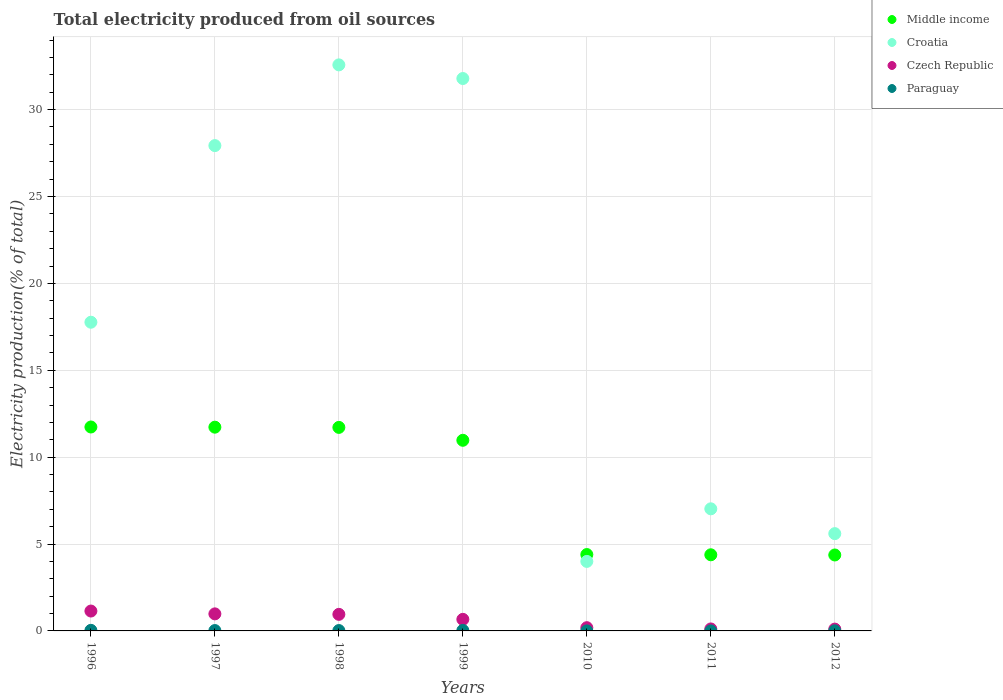How many different coloured dotlines are there?
Your answer should be compact. 4. Is the number of dotlines equal to the number of legend labels?
Offer a terse response. Yes. What is the total electricity produced in Croatia in 1999?
Your answer should be compact. 31.79. Across all years, what is the maximum total electricity produced in Croatia?
Keep it short and to the point. 32.57. Across all years, what is the minimum total electricity produced in Croatia?
Offer a very short reply. 4. In which year was the total electricity produced in Croatia maximum?
Offer a terse response. 1998. What is the total total electricity produced in Croatia in the graph?
Your answer should be very brief. 126.68. What is the difference between the total electricity produced in Paraguay in 1996 and that in 1997?
Give a very brief answer. 0.01. What is the difference between the total electricity produced in Paraguay in 2011 and the total electricity produced in Croatia in 1996?
Offer a very short reply. -17.76. What is the average total electricity produced in Croatia per year?
Ensure brevity in your answer.  18.1. In the year 1999, what is the difference between the total electricity produced in Paraguay and total electricity produced in Croatia?
Offer a very short reply. -31.76. In how many years, is the total electricity produced in Czech Republic greater than 5 %?
Keep it short and to the point. 0. What is the ratio of the total electricity produced in Paraguay in 1997 to that in 2010?
Give a very brief answer. 11.69. Is the total electricity produced in Middle income in 1997 less than that in 2011?
Your answer should be very brief. No. What is the difference between the highest and the second highest total electricity produced in Middle income?
Your answer should be compact. 0.01. What is the difference between the highest and the lowest total electricity produced in Middle income?
Your answer should be compact. 7.37. In how many years, is the total electricity produced in Middle income greater than the average total electricity produced in Middle income taken over all years?
Give a very brief answer. 4. Is the sum of the total electricity produced in Middle income in 1997 and 2012 greater than the maximum total electricity produced in Czech Republic across all years?
Ensure brevity in your answer.  Yes. Does the total electricity produced in Paraguay monotonically increase over the years?
Your answer should be very brief. No. What is the difference between two consecutive major ticks on the Y-axis?
Keep it short and to the point. 5. Are the values on the major ticks of Y-axis written in scientific E-notation?
Your response must be concise. No. Does the graph contain grids?
Keep it short and to the point. Yes. Where does the legend appear in the graph?
Your answer should be very brief. Top right. How many legend labels are there?
Provide a succinct answer. 4. What is the title of the graph?
Provide a succinct answer. Total electricity produced from oil sources. Does "France" appear as one of the legend labels in the graph?
Offer a very short reply. No. What is the label or title of the X-axis?
Ensure brevity in your answer.  Years. What is the label or title of the Y-axis?
Provide a short and direct response. Electricity production(% of total). What is the Electricity production(% of total) of Middle income in 1996?
Make the answer very short. 11.74. What is the Electricity production(% of total) in Croatia in 1996?
Ensure brevity in your answer.  17.76. What is the Electricity production(% of total) of Czech Republic in 1996?
Provide a short and direct response. 1.14. What is the Electricity production(% of total) in Paraguay in 1996?
Keep it short and to the point. 0.03. What is the Electricity production(% of total) in Middle income in 1997?
Ensure brevity in your answer.  11.73. What is the Electricity production(% of total) of Croatia in 1997?
Provide a short and direct response. 27.93. What is the Electricity production(% of total) of Czech Republic in 1997?
Your answer should be compact. 0.98. What is the Electricity production(% of total) of Paraguay in 1997?
Provide a short and direct response. 0.02. What is the Electricity production(% of total) of Middle income in 1998?
Make the answer very short. 11.71. What is the Electricity production(% of total) in Croatia in 1998?
Make the answer very short. 32.57. What is the Electricity production(% of total) in Czech Republic in 1998?
Your response must be concise. 0.95. What is the Electricity production(% of total) in Paraguay in 1998?
Keep it short and to the point. 0.02. What is the Electricity production(% of total) of Middle income in 1999?
Your answer should be very brief. 10.97. What is the Electricity production(% of total) in Croatia in 1999?
Keep it short and to the point. 31.79. What is the Electricity production(% of total) in Czech Republic in 1999?
Keep it short and to the point. 0.67. What is the Electricity production(% of total) in Paraguay in 1999?
Provide a succinct answer. 0.03. What is the Electricity production(% of total) in Middle income in 2010?
Your response must be concise. 4.39. What is the Electricity production(% of total) of Croatia in 2010?
Your answer should be very brief. 4. What is the Electricity production(% of total) in Czech Republic in 2010?
Keep it short and to the point. 0.19. What is the Electricity production(% of total) of Paraguay in 2010?
Provide a short and direct response. 0. What is the Electricity production(% of total) of Middle income in 2011?
Ensure brevity in your answer.  4.38. What is the Electricity production(% of total) in Croatia in 2011?
Provide a short and direct response. 7.03. What is the Electricity production(% of total) in Czech Republic in 2011?
Your response must be concise. 0.11. What is the Electricity production(% of total) in Paraguay in 2011?
Offer a terse response. 0. What is the Electricity production(% of total) of Middle income in 2012?
Offer a terse response. 4.37. What is the Electricity production(% of total) in Croatia in 2012?
Your response must be concise. 5.6. What is the Electricity production(% of total) in Czech Republic in 2012?
Your response must be concise. 0.1. What is the Electricity production(% of total) in Paraguay in 2012?
Your response must be concise. 0. Across all years, what is the maximum Electricity production(% of total) in Middle income?
Provide a short and direct response. 11.74. Across all years, what is the maximum Electricity production(% of total) in Croatia?
Your response must be concise. 32.57. Across all years, what is the maximum Electricity production(% of total) in Czech Republic?
Keep it short and to the point. 1.14. Across all years, what is the maximum Electricity production(% of total) in Paraguay?
Offer a terse response. 0.03. Across all years, what is the minimum Electricity production(% of total) in Middle income?
Keep it short and to the point. 4.37. Across all years, what is the minimum Electricity production(% of total) in Croatia?
Your response must be concise. 4. Across all years, what is the minimum Electricity production(% of total) of Czech Republic?
Offer a terse response. 0.1. Across all years, what is the minimum Electricity production(% of total) in Paraguay?
Ensure brevity in your answer.  0. What is the total Electricity production(% of total) in Middle income in the graph?
Keep it short and to the point. 59.29. What is the total Electricity production(% of total) of Croatia in the graph?
Offer a terse response. 126.68. What is the total Electricity production(% of total) in Czech Republic in the graph?
Keep it short and to the point. 4.15. What is the total Electricity production(% of total) in Paraguay in the graph?
Provide a short and direct response. 0.11. What is the difference between the Electricity production(% of total) in Middle income in 1996 and that in 1997?
Ensure brevity in your answer.  0.01. What is the difference between the Electricity production(% of total) in Croatia in 1996 and that in 1997?
Keep it short and to the point. -10.16. What is the difference between the Electricity production(% of total) of Czech Republic in 1996 and that in 1997?
Provide a short and direct response. 0.16. What is the difference between the Electricity production(% of total) in Paraguay in 1996 and that in 1997?
Provide a short and direct response. 0.01. What is the difference between the Electricity production(% of total) in Middle income in 1996 and that in 1998?
Provide a succinct answer. 0.02. What is the difference between the Electricity production(% of total) in Croatia in 1996 and that in 1998?
Your answer should be compact. -14.81. What is the difference between the Electricity production(% of total) in Czech Republic in 1996 and that in 1998?
Give a very brief answer. 0.19. What is the difference between the Electricity production(% of total) of Paraguay in 1996 and that in 1998?
Offer a terse response. 0.01. What is the difference between the Electricity production(% of total) of Middle income in 1996 and that in 1999?
Provide a succinct answer. 0.76. What is the difference between the Electricity production(% of total) of Croatia in 1996 and that in 1999?
Provide a succinct answer. -14.02. What is the difference between the Electricity production(% of total) in Czech Republic in 1996 and that in 1999?
Make the answer very short. 0.48. What is the difference between the Electricity production(% of total) in Paraguay in 1996 and that in 1999?
Your response must be concise. 0. What is the difference between the Electricity production(% of total) of Middle income in 1996 and that in 2010?
Your answer should be very brief. 7.34. What is the difference between the Electricity production(% of total) of Croatia in 1996 and that in 2010?
Provide a succinct answer. 13.76. What is the difference between the Electricity production(% of total) in Czech Republic in 1996 and that in 2010?
Make the answer very short. 0.96. What is the difference between the Electricity production(% of total) in Paraguay in 1996 and that in 2010?
Offer a terse response. 0.03. What is the difference between the Electricity production(% of total) in Middle income in 1996 and that in 2011?
Ensure brevity in your answer.  7.35. What is the difference between the Electricity production(% of total) of Croatia in 1996 and that in 2011?
Your answer should be very brief. 10.74. What is the difference between the Electricity production(% of total) in Czech Republic in 1996 and that in 2011?
Offer a terse response. 1.03. What is the difference between the Electricity production(% of total) in Paraguay in 1996 and that in 2011?
Provide a succinct answer. 0.03. What is the difference between the Electricity production(% of total) of Middle income in 1996 and that in 2012?
Make the answer very short. 7.37. What is the difference between the Electricity production(% of total) in Croatia in 1996 and that in 2012?
Offer a terse response. 12.17. What is the difference between the Electricity production(% of total) in Czech Republic in 1996 and that in 2012?
Give a very brief answer. 1.04. What is the difference between the Electricity production(% of total) of Paraguay in 1996 and that in 2012?
Your answer should be compact. 0.03. What is the difference between the Electricity production(% of total) of Middle income in 1997 and that in 1998?
Your answer should be compact. 0.01. What is the difference between the Electricity production(% of total) of Croatia in 1997 and that in 1998?
Your response must be concise. -4.65. What is the difference between the Electricity production(% of total) of Czech Republic in 1997 and that in 1998?
Your response must be concise. 0.03. What is the difference between the Electricity production(% of total) in Paraguay in 1997 and that in 1998?
Your answer should be very brief. 0. What is the difference between the Electricity production(% of total) of Middle income in 1997 and that in 1999?
Offer a very short reply. 0.75. What is the difference between the Electricity production(% of total) in Croatia in 1997 and that in 1999?
Give a very brief answer. -3.86. What is the difference between the Electricity production(% of total) of Czech Republic in 1997 and that in 1999?
Your response must be concise. 0.32. What is the difference between the Electricity production(% of total) in Paraguay in 1997 and that in 1999?
Provide a succinct answer. -0.01. What is the difference between the Electricity production(% of total) in Middle income in 1997 and that in 2010?
Offer a very short reply. 7.33. What is the difference between the Electricity production(% of total) of Croatia in 1997 and that in 2010?
Provide a short and direct response. 23.93. What is the difference between the Electricity production(% of total) of Czech Republic in 1997 and that in 2010?
Your response must be concise. 0.79. What is the difference between the Electricity production(% of total) in Paraguay in 1997 and that in 2010?
Your answer should be compact. 0.02. What is the difference between the Electricity production(% of total) in Middle income in 1997 and that in 2011?
Offer a terse response. 7.34. What is the difference between the Electricity production(% of total) in Croatia in 1997 and that in 2011?
Offer a terse response. 20.9. What is the difference between the Electricity production(% of total) of Czech Republic in 1997 and that in 2011?
Your response must be concise. 0.87. What is the difference between the Electricity production(% of total) in Paraguay in 1997 and that in 2011?
Keep it short and to the point. 0.02. What is the difference between the Electricity production(% of total) in Middle income in 1997 and that in 2012?
Your answer should be compact. 7.35. What is the difference between the Electricity production(% of total) in Croatia in 1997 and that in 2012?
Offer a terse response. 22.33. What is the difference between the Electricity production(% of total) of Czech Republic in 1997 and that in 2012?
Your answer should be very brief. 0.88. What is the difference between the Electricity production(% of total) of Paraguay in 1997 and that in 2012?
Offer a very short reply. 0.02. What is the difference between the Electricity production(% of total) in Middle income in 1998 and that in 1999?
Your answer should be very brief. 0.74. What is the difference between the Electricity production(% of total) in Croatia in 1998 and that in 1999?
Your answer should be compact. 0.78. What is the difference between the Electricity production(% of total) in Czech Republic in 1998 and that in 1999?
Your answer should be compact. 0.29. What is the difference between the Electricity production(% of total) of Paraguay in 1998 and that in 1999?
Give a very brief answer. -0.01. What is the difference between the Electricity production(% of total) of Middle income in 1998 and that in 2010?
Your answer should be very brief. 7.32. What is the difference between the Electricity production(% of total) in Croatia in 1998 and that in 2010?
Your answer should be very brief. 28.57. What is the difference between the Electricity production(% of total) in Czech Republic in 1998 and that in 2010?
Your response must be concise. 0.77. What is the difference between the Electricity production(% of total) of Paraguay in 1998 and that in 2010?
Provide a short and direct response. 0.02. What is the difference between the Electricity production(% of total) in Middle income in 1998 and that in 2011?
Keep it short and to the point. 7.33. What is the difference between the Electricity production(% of total) of Croatia in 1998 and that in 2011?
Your answer should be compact. 25.55. What is the difference between the Electricity production(% of total) of Czech Republic in 1998 and that in 2011?
Make the answer very short. 0.84. What is the difference between the Electricity production(% of total) of Paraguay in 1998 and that in 2011?
Your response must be concise. 0.02. What is the difference between the Electricity production(% of total) of Middle income in 1998 and that in 2012?
Offer a very short reply. 7.34. What is the difference between the Electricity production(% of total) of Croatia in 1998 and that in 2012?
Ensure brevity in your answer.  26.98. What is the difference between the Electricity production(% of total) of Czech Republic in 1998 and that in 2012?
Provide a short and direct response. 0.85. What is the difference between the Electricity production(% of total) of Paraguay in 1998 and that in 2012?
Offer a terse response. 0.02. What is the difference between the Electricity production(% of total) of Middle income in 1999 and that in 2010?
Make the answer very short. 6.58. What is the difference between the Electricity production(% of total) of Croatia in 1999 and that in 2010?
Make the answer very short. 27.79. What is the difference between the Electricity production(% of total) in Czech Republic in 1999 and that in 2010?
Provide a short and direct response. 0.48. What is the difference between the Electricity production(% of total) in Paraguay in 1999 and that in 2010?
Keep it short and to the point. 0.03. What is the difference between the Electricity production(% of total) of Middle income in 1999 and that in 2011?
Keep it short and to the point. 6.59. What is the difference between the Electricity production(% of total) in Croatia in 1999 and that in 2011?
Offer a terse response. 24.76. What is the difference between the Electricity production(% of total) in Czech Republic in 1999 and that in 2011?
Your answer should be compact. 0.55. What is the difference between the Electricity production(% of total) in Paraguay in 1999 and that in 2011?
Provide a succinct answer. 0.03. What is the difference between the Electricity production(% of total) of Middle income in 1999 and that in 2012?
Your answer should be very brief. 6.6. What is the difference between the Electricity production(% of total) of Croatia in 1999 and that in 2012?
Keep it short and to the point. 26.19. What is the difference between the Electricity production(% of total) in Czech Republic in 1999 and that in 2012?
Give a very brief answer. 0.56. What is the difference between the Electricity production(% of total) of Paraguay in 1999 and that in 2012?
Offer a terse response. 0.02. What is the difference between the Electricity production(% of total) of Middle income in 2010 and that in 2011?
Your response must be concise. 0.01. What is the difference between the Electricity production(% of total) of Croatia in 2010 and that in 2011?
Your answer should be very brief. -3.03. What is the difference between the Electricity production(% of total) of Czech Republic in 2010 and that in 2011?
Your response must be concise. 0.07. What is the difference between the Electricity production(% of total) in Paraguay in 2010 and that in 2011?
Make the answer very short. 0. What is the difference between the Electricity production(% of total) of Middle income in 2010 and that in 2012?
Give a very brief answer. 0.02. What is the difference between the Electricity production(% of total) in Croatia in 2010 and that in 2012?
Keep it short and to the point. -1.6. What is the difference between the Electricity production(% of total) in Czech Republic in 2010 and that in 2012?
Offer a very short reply. 0.08. What is the difference between the Electricity production(% of total) in Paraguay in 2010 and that in 2012?
Offer a very short reply. -0. What is the difference between the Electricity production(% of total) in Middle income in 2011 and that in 2012?
Give a very brief answer. 0.01. What is the difference between the Electricity production(% of total) of Croatia in 2011 and that in 2012?
Ensure brevity in your answer.  1.43. What is the difference between the Electricity production(% of total) of Czech Republic in 2011 and that in 2012?
Your response must be concise. 0.01. What is the difference between the Electricity production(% of total) in Paraguay in 2011 and that in 2012?
Ensure brevity in your answer.  -0. What is the difference between the Electricity production(% of total) of Middle income in 1996 and the Electricity production(% of total) of Croatia in 1997?
Offer a terse response. -16.19. What is the difference between the Electricity production(% of total) of Middle income in 1996 and the Electricity production(% of total) of Czech Republic in 1997?
Your answer should be very brief. 10.75. What is the difference between the Electricity production(% of total) in Middle income in 1996 and the Electricity production(% of total) in Paraguay in 1997?
Ensure brevity in your answer.  11.71. What is the difference between the Electricity production(% of total) in Croatia in 1996 and the Electricity production(% of total) in Czech Republic in 1997?
Your answer should be very brief. 16.78. What is the difference between the Electricity production(% of total) of Croatia in 1996 and the Electricity production(% of total) of Paraguay in 1997?
Keep it short and to the point. 17.74. What is the difference between the Electricity production(% of total) of Czech Republic in 1996 and the Electricity production(% of total) of Paraguay in 1997?
Provide a short and direct response. 1.12. What is the difference between the Electricity production(% of total) of Middle income in 1996 and the Electricity production(% of total) of Croatia in 1998?
Provide a short and direct response. -20.84. What is the difference between the Electricity production(% of total) of Middle income in 1996 and the Electricity production(% of total) of Czech Republic in 1998?
Keep it short and to the point. 10.78. What is the difference between the Electricity production(% of total) in Middle income in 1996 and the Electricity production(% of total) in Paraguay in 1998?
Provide a short and direct response. 11.71. What is the difference between the Electricity production(% of total) in Croatia in 1996 and the Electricity production(% of total) in Czech Republic in 1998?
Provide a short and direct response. 16.81. What is the difference between the Electricity production(% of total) in Croatia in 1996 and the Electricity production(% of total) in Paraguay in 1998?
Your answer should be compact. 17.74. What is the difference between the Electricity production(% of total) in Czech Republic in 1996 and the Electricity production(% of total) in Paraguay in 1998?
Make the answer very short. 1.12. What is the difference between the Electricity production(% of total) of Middle income in 1996 and the Electricity production(% of total) of Croatia in 1999?
Give a very brief answer. -20.05. What is the difference between the Electricity production(% of total) in Middle income in 1996 and the Electricity production(% of total) in Czech Republic in 1999?
Provide a short and direct response. 11.07. What is the difference between the Electricity production(% of total) of Middle income in 1996 and the Electricity production(% of total) of Paraguay in 1999?
Your answer should be compact. 11.71. What is the difference between the Electricity production(% of total) of Croatia in 1996 and the Electricity production(% of total) of Czech Republic in 1999?
Make the answer very short. 17.1. What is the difference between the Electricity production(% of total) in Croatia in 1996 and the Electricity production(% of total) in Paraguay in 1999?
Give a very brief answer. 17.74. What is the difference between the Electricity production(% of total) of Czech Republic in 1996 and the Electricity production(% of total) of Paraguay in 1999?
Your answer should be compact. 1.11. What is the difference between the Electricity production(% of total) of Middle income in 1996 and the Electricity production(% of total) of Croatia in 2010?
Give a very brief answer. 7.74. What is the difference between the Electricity production(% of total) in Middle income in 1996 and the Electricity production(% of total) in Czech Republic in 2010?
Make the answer very short. 11.55. What is the difference between the Electricity production(% of total) of Middle income in 1996 and the Electricity production(% of total) of Paraguay in 2010?
Your response must be concise. 11.73. What is the difference between the Electricity production(% of total) in Croatia in 1996 and the Electricity production(% of total) in Czech Republic in 2010?
Provide a succinct answer. 17.58. What is the difference between the Electricity production(% of total) in Croatia in 1996 and the Electricity production(% of total) in Paraguay in 2010?
Offer a very short reply. 17.76. What is the difference between the Electricity production(% of total) in Czech Republic in 1996 and the Electricity production(% of total) in Paraguay in 2010?
Make the answer very short. 1.14. What is the difference between the Electricity production(% of total) of Middle income in 1996 and the Electricity production(% of total) of Croatia in 2011?
Provide a succinct answer. 4.71. What is the difference between the Electricity production(% of total) of Middle income in 1996 and the Electricity production(% of total) of Czech Republic in 2011?
Give a very brief answer. 11.62. What is the difference between the Electricity production(% of total) of Middle income in 1996 and the Electricity production(% of total) of Paraguay in 2011?
Give a very brief answer. 11.73. What is the difference between the Electricity production(% of total) in Croatia in 1996 and the Electricity production(% of total) in Czech Republic in 2011?
Offer a terse response. 17.65. What is the difference between the Electricity production(% of total) in Croatia in 1996 and the Electricity production(% of total) in Paraguay in 2011?
Provide a succinct answer. 17.76. What is the difference between the Electricity production(% of total) in Czech Republic in 1996 and the Electricity production(% of total) in Paraguay in 2011?
Your answer should be compact. 1.14. What is the difference between the Electricity production(% of total) in Middle income in 1996 and the Electricity production(% of total) in Croatia in 2012?
Give a very brief answer. 6.14. What is the difference between the Electricity production(% of total) of Middle income in 1996 and the Electricity production(% of total) of Czech Republic in 2012?
Make the answer very short. 11.63. What is the difference between the Electricity production(% of total) in Middle income in 1996 and the Electricity production(% of total) in Paraguay in 2012?
Ensure brevity in your answer.  11.73. What is the difference between the Electricity production(% of total) of Croatia in 1996 and the Electricity production(% of total) of Czech Republic in 2012?
Make the answer very short. 17.66. What is the difference between the Electricity production(% of total) in Croatia in 1996 and the Electricity production(% of total) in Paraguay in 2012?
Offer a terse response. 17.76. What is the difference between the Electricity production(% of total) of Czech Republic in 1996 and the Electricity production(% of total) of Paraguay in 2012?
Make the answer very short. 1.14. What is the difference between the Electricity production(% of total) of Middle income in 1997 and the Electricity production(% of total) of Croatia in 1998?
Give a very brief answer. -20.85. What is the difference between the Electricity production(% of total) in Middle income in 1997 and the Electricity production(% of total) in Czech Republic in 1998?
Offer a very short reply. 10.77. What is the difference between the Electricity production(% of total) in Middle income in 1997 and the Electricity production(% of total) in Paraguay in 1998?
Ensure brevity in your answer.  11.7. What is the difference between the Electricity production(% of total) of Croatia in 1997 and the Electricity production(% of total) of Czech Republic in 1998?
Your response must be concise. 26.98. What is the difference between the Electricity production(% of total) of Croatia in 1997 and the Electricity production(% of total) of Paraguay in 1998?
Your answer should be compact. 27.91. What is the difference between the Electricity production(% of total) of Czech Republic in 1997 and the Electricity production(% of total) of Paraguay in 1998?
Ensure brevity in your answer.  0.96. What is the difference between the Electricity production(% of total) in Middle income in 1997 and the Electricity production(% of total) in Croatia in 1999?
Provide a succinct answer. -20.06. What is the difference between the Electricity production(% of total) in Middle income in 1997 and the Electricity production(% of total) in Czech Republic in 1999?
Your answer should be very brief. 11.06. What is the difference between the Electricity production(% of total) of Middle income in 1997 and the Electricity production(% of total) of Paraguay in 1999?
Your answer should be very brief. 11.7. What is the difference between the Electricity production(% of total) in Croatia in 1997 and the Electricity production(% of total) in Czech Republic in 1999?
Your response must be concise. 27.26. What is the difference between the Electricity production(% of total) in Croatia in 1997 and the Electricity production(% of total) in Paraguay in 1999?
Your answer should be compact. 27.9. What is the difference between the Electricity production(% of total) in Czech Republic in 1997 and the Electricity production(% of total) in Paraguay in 1999?
Offer a terse response. 0.95. What is the difference between the Electricity production(% of total) of Middle income in 1997 and the Electricity production(% of total) of Croatia in 2010?
Offer a terse response. 7.72. What is the difference between the Electricity production(% of total) of Middle income in 1997 and the Electricity production(% of total) of Czech Republic in 2010?
Offer a terse response. 11.54. What is the difference between the Electricity production(% of total) of Middle income in 1997 and the Electricity production(% of total) of Paraguay in 2010?
Provide a succinct answer. 11.72. What is the difference between the Electricity production(% of total) of Croatia in 1997 and the Electricity production(% of total) of Czech Republic in 2010?
Your response must be concise. 27.74. What is the difference between the Electricity production(% of total) of Croatia in 1997 and the Electricity production(% of total) of Paraguay in 2010?
Provide a short and direct response. 27.93. What is the difference between the Electricity production(% of total) of Czech Republic in 1997 and the Electricity production(% of total) of Paraguay in 2010?
Your answer should be compact. 0.98. What is the difference between the Electricity production(% of total) of Middle income in 1997 and the Electricity production(% of total) of Croatia in 2011?
Give a very brief answer. 4.7. What is the difference between the Electricity production(% of total) in Middle income in 1997 and the Electricity production(% of total) in Czech Republic in 2011?
Provide a succinct answer. 11.61. What is the difference between the Electricity production(% of total) in Middle income in 1997 and the Electricity production(% of total) in Paraguay in 2011?
Ensure brevity in your answer.  11.72. What is the difference between the Electricity production(% of total) in Croatia in 1997 and the Electricity production(% of total) in Czech Republic in 2011?
Keep it short and to the point. 27.81. What is the difference between the Electricity production(% of total) in Croatia in 1997 and the Electricity production(% of total) in Paraguay in 2011?
Ensure brevity in your answer.  27.93. What is the difference between the Electricity production(% of total) of Czech Republic in 1997 and the Electricity production(% of total) of Paraguay in 2011?
Your response must be concise. 0.98. What is the difference between the Electricity production(% of total) of Middle income in 1997 and the Electricity production(% of total) of Croatia in 2012?
Ensure brevity in your answer.  6.13. What is the difference between the Electricity production(% of total) of Middle income in 1997 and the Electricity production(% of total) of Czech Republic in 2012?
Ensure brevity in your answer.  11.62. What is the difference between the Electricity production(% of total) in Middle income in 1997 and the Electricity production(% of total) in Paraguay in 2012?
Your answer should be very brief. 11.72. What is the difference between the Electricity production(% of total) of Croatia in 1997 and the Electricity production(% of total) of Czech Republic in 2012?
Give a very brief answer. 27.82. What is the difference between the Electricity production(% of total) in Croatia in 1997 and the Electricity production(% of total) in Paraguay in 2012?
Your response must be concise. 27.92. What is the difference between the Electricity production(% of total) in Czech Republic in 1997 and the Electricity production(% of total) in Paraguay in 2012?
Your response must be concise. 0.98. What is the difference between the Electricity production(% of total) of Middle income in 1998 and the Electricity production(% of total) of Croatia in 1999?
Your answer should be compact. -20.08. What is the difference between the Electricity production(% of total) of Middle income in 1998 and the Electricity production(% of total) of Czech Republic in 1999?
Your answer should be very brief. 11.05. What is the difference between the Electricity production(% of total) in Middle income in 1998 and the Electricity production(% of total) in Paraguay in 1999?
Keep it short and to the point. 11.68. What is the difference between the Electricity production(% of total) of Croatia in 1998 and the Electricity production(% of total) of Czech Republic in 1999?
Ensure brevity in your answer.  31.91. What is the difference between the Electricity production(% of total) of Croatia in 1998 and the Electricity production(% of total) of Paraguay in 1999?
Your answer should be very brief. 32.55. What is the difference between the Electricity production(% of total) of Czech Republic in 1998 and the Electricity production(% of total) of Paraguay in 1999?
Make the answer very short. 0.92. What is the difference between the Electricity production(% of total) in Middle income in 1998 and the Electricity production(% of total) in Croatia in 2010?
Ensure brevity in your answer.  7.71. What is the difference between the Electricity production(% of total) of Middle income in 1998 and the Electricity production(% of total) of Czech Republic in 2010?
Offer a terse response. 11.53. What is the difference between the Electricity production(% of total) of Middle income in 1998 and the Electricity production(% of total) of Paraguay in 2010?
Give a very brief answer. 11.71. What is the difference between the Electricity production(% of total) in Croatia in 1998 and the Electricity production(% of total) in Czech Republic in 2010?
Give a very brief answer. 32.39. What is the difference between the Electricity production(% of total) in Croatia in 1998 and the Electricity production(% of total) in Paraguay in 2010?
Make the answer very short. 32.57. What is the difference between the Electricity production(% of total) in Czech Republic in 1998 and the Electricity production(% of total) in Paraguay in 2010?
Your answer should be very brief. 0.95. What is the difference between the Electricity production(% of total) of Middle income in 1998 and the Electricity production(% of total) of Croatia in 2011?
Give a very brief answer. 4.69. What is the difference between the Electricity production(% of total) in Middle income in 1998 and the Electricity production(% of total) in Czech Republic in 2011?
Make the answer very short. 11.6. What is the difference between the Electricity production(% of total) in Middle income in 1998 and the Electricity production(% of total) in Paraguay in 2011?
Your answer should be compact. 11.71. What is the difference between the Electricity production(% of total) of Croatia in 1998 and the Electricity production(% of total) of Czech Republic in 2011?
Make the answer very short. 32.46. What is the difference between the Electricity production(% of total) of Croatia in 1998 and the Electricity production(% of total) of Paraguay in 2011?
Give a very brief answer. 32.57. What is the difference between the Electricity production(% of total) in Czech Republic in 1998 and the Electricity production(% of total) in Paraguay in 2011?
Your answer should be compact. 0.95. What is the difference between the Electricity production(% of total) in Middle income in 1998 and the Electricity production(% of total) in Croatia in 2012?
Provide a succinct answer. 6.11. What is the difference between the Electricity production(% of total) in Middle income in 1998 and the Electricity production(% of total) in Czech Republic in 2012?
Ensure brevity in your answer.  11.61. What is the difference between the Electricity production(% of total) in Middle income in 1998 and the Electricity production(% of total) in Paraguay in 2012?
Keep it short and to the point. 11.71. What is the difference between the Electricity production(% of total) in Croatia in 1998 and the Electricity production(% of total) in Czech Republic in 2012?
Your answer should be very brief. 32.47. What is the difference between the Electricity production(% of total) in Croatia in 1998 and the Electricity production(% of total) in Paraguay in 2012?
Your answer should be compact. 32.57. What is the difference between the Electricity production(% of total) in Czech Republic in 1998 and the Electricity production(% of total) in Paraguay in 2012?
Keep it short and to the point. 0.95. What is the difference between the Electricity production(% of total) in Middle income in 1999 and the Electricity production(% of total) in Croatia in 2010?
Your answer should be compact. 6.97. What is the difference between the Electricity production(% of total) of Middle income in 1999 and the Electricity production(% of total) of Czech Republic in 2010?
Make the answer very short. 10.78. What is the difference between the Electricity production(% of total) in Middle income in 1999 and the Electricity production(% of total) in Paraguay in 2010?
Your answer should be compact. 10.97. What is the difference between the Electricity production(% of total) in Croatia in 1999 and the Electricity production(% of total) in Czech Republic in 2010?
Ensure brevity in your answer.  31.6. What is the difference between the Electricity production(% of total) of Croatia in 1999 and the Electricity production(% of total) of Paraguay in 2010?
Keep it short and to the point. 31.79. What is the difference between the Electricity production(% of total) in Czech Republic in 1999 and the Electricity production(% of total) in Paraguay in 2010?
Give a very brief answer. 0.66. What is the difference between the Electricity production(% of total) in Middle income in 1999 and the Electricity production(% of total) in Croatia in 2011?
Your answer should be compact. 3.94. What is the difference between the Electricity production(% of total) in Middle income in 1999 and the Electricity production(% of total) in Czech Republic in 2011?
Offer a very short reply. 10.86. What is the difference between the Electricity production(% of total) in Middle income in 1999 and the Electricity production(% of total) in Paraguay in 2011?
Offer a terse response. 10.97. What is the difference between the Electricity production(% of total) of Croatia in 1999 and the Electricity production(% of total) of Czech Republic in 2011?
Keep it short and to the point. 31.68. What is the difference between the Electricity production(% of total) of Croatia in 1999 and the Electricity production(% of total) of Paraguay in 2011?
Your response must be concise. 31.79. What is the difference between the Electricity production(% of total) of Czech Republic in 1999 and the Electricity production(% of total) of Paraguay in 2011?
Keep it short and to the point. 0.66. What is the difference between the Electricity production(% of total) of Middle income in 1999 and the Electricity production(% of total) of Croatia in 2012?
Give a very brief answer. 5.37. What is the difference between the Electricity production(% of total) of Middle income in 1999 and the Electricity production(% of total) of Czech Republic in 2012?
Your response must be concise. 10.87. What is the difference between the Electricity production(% of total) in Middle income in 1999 and the Electricity production(% of total) in Paraguay in 2012?
Make the answer very short. 10.97. What is the difference between the Electricity production(% of total) in Croatia in 1999 and the Electricity production(% of total) in Czech Republic in 2012?
Ensure brevity in your answer.  31.68. What is the difference between the Electricity production(% of total) of Croatia in 1999 and the Electricity production(% of total) of Paraguay in 2012?
Provide a short and direct response. 31.78. What is the difference between the Electricity production(% of total) of Czech Republic in 1999 and the Electricity production(% of total) of Paraguay in 2012?
Your answer should be compact. 0.66. What is the difference between the Electricity production(% of total) in Middle income in 2010 and the Electricity production(% of total) in Croatia in 2011?
Keep it short and to the point. -2.63. What is the difference between the Electricity production(% of total) in Middle income in 2010 and the Electricity production(% of total) in Czech Republic in 2011?
Offer a terse response. 4.28. What is the difference between the Electricity production(% of total) in Middle income in 2010 and the Electricity production(% of total) in Paraguay in 2011?
Provide a short and direct response. 4.39. What is the difference between the Electricity production(% of total) of Croatia in 2010 and the Electricity production(% of total) of Czech Republic in 2011?
Provide a short and direct response. 3.89. What is the difference between the Electricity production(% of total) in Croatia in 2010 and the Electricity production(% of total) in Paraguay in 2011?
Your response must be concise. 4. What is the difference between the Electricity production(% of total) of Czech Republic in 2010 and the Electricity production(% of total) of Paraguay in 2011?
Keep it short and to the point. 0.18. What is the difference between the Electricity production(% of total) in Middle income in 2010 and the Electricity production(% of total) in Croatia in 2012?
Provide a succinct answer. -1.2. What is the difference between the Electricity production(% of total) of Middle income in 2010 and the Electricity production(% of total) of Czech Republic in 2012?
Make the answer very short. 4.29. What is the difference between the Electricity production(% of total) in Middle income in 2010 and the Electricity production(% of total) in Paraguay in 2012?
Provide a succinct answer. 4.39. What is the difference between the Electricity production(% of total) in Croatia in 2010 and the Electricity production(% of total) in Czech Republic in 2012?
Provide a short and direct response. 3.9. What is the difference between the Electricity production(% of total) of Croatia in 2010 and the Electricity production(% of total) of Paraguay in 2012?
Keep it short and to the point. 4. What is the difference between the Electricity production(% of total) in Czech Republic in 2010 and the Electricity production(% of total) in Paraguay in 2012?
Ensure brevity in your answer.  0.18. What is the difference between the Electricity production(% of total) in Middle income in 2011 and the Electricity production(% of total) in Croatia in 2012?
Your response must be concise. -1.22. What is the difference between the Electricity production(% of total) in Middle income in 2011 and the Electricity production(% of total) in Czech Republic in 2012?
Your answer should be very brief. 4.28. What is the difference between the Electricity production(% of total) of Middle income in 2011 and the Electricity production(% of total) of Paraguay in 2012?
Your answer should be compact. 4.38. What is the difference between the Electricity production(% of total) in Croatia in 2011 and the Electricity production(% of total) in Czech Republic in 2012?
Your response must be concise. 6.92. What is the difference between the Electricity production(% of total) of Croatia in 2011 and the Electricity production(% of total) of Paraguay in 2012?
Provide a succinct answer. 7.02. What is the difference between the Electricity production(% of total) of Czech Republic in 2011 and the Electricity production(% of total) of Paraguay in 2012?
Ensure brevity in your answer.  0.11. What is the average Electricity production(% of total) of Middle income per year?
Offer a terse response. 8.47. What is the average Electricity production(% of total) of Croatia per year?
Provide a short and direct response. 18.1. What is the average Electricity production(% of total) of Czech Republic per year?
Make the answer very short. 0.59. What is the average Electricity production(% of total) of Paraguay per year?
Keep it short and to the point. 0.02. In the year 1996, what is the difference between the Electricity production(% of total) in Middle income and Electricity production(% of total) in Croatia?
Ensure brevity in your answer.  -6.03. In the year 1996, what is the difference between the Electricity production(% of total) in Middle income and Electricity production(% of total) in Czech Republic?
Ensure brevity in your answer.  10.59. In the year 1996, what is the difference between the Electricity production(% of total) in Middle income and Electricity production(% of total) in Paraguay?
Provide a short and direct response. 11.7. In the year 1996, what is the difference between the Electricity production(% of total) of Croatia and Electricity production(% of total) of Czech Republic?
Your answer should be very brief. 16.62. In the year 1996, what is the difference between the Electricity production(% of total) of Croatia and Electricity production(% of total) of Paraguay?
Your response must be concise. 17.73. In the year 1996, what is the difference between the Electricity production(% of total) in Czech Republic and Electricity production(% of total) in Paraguay?
Give a very brief answer. 1.11. In the year 1997, what is the difference between the Electricity production(% of total) in Middle income and Electricity production(% of total) in Croatia?
Make the answer very short. -16.2. In the year 1997, what is the difference between the Electricity production(% of total) in Middle income and Electricity production(% of total) in Czech Republic?
Provide a succinct answer. 10.74. In the year 1997, what is the difference between the Electricity production(% of total) of Middle income and Electricity production(% of total) of Paraguay?
Provide a succinct answer. 11.7. In the year 1997, what is the difference between the Electricity production(% of total) of Croatia and Electricity production(% of total) of Czech Republic?
Provide a succinct answer. 26.95. In the year 1997, what is the difference between the Electricity production(% of total) in Croatia and Electricity production(% of total) in Paraguay?
Give a very brief answer. 27.91. In the year 1997, what is the difference between the Electricity production(% of total) of Czech Republic and Electricity production(% of total) of Paraguay?
Provide a short and direct response. 0.96. In the year 1998, what is the difference between the Electricity production(% of total) in Middle income and Electricity production(% of total) in Croatia?
Keep it short and to the point. -20.86. In the year 1998, what is the difference between the Electricity production(% of total) in Middle income and Electricity production(% of total) in Czech Republic?
Offer a very short reply. 10.76. In the year 1998, what is the difference between the Electricity production(% of total) in Middle income and Electricity production(% of total) in Paraguay?
Your response must be concise. 11.69. In the year 1998, what is the difference between the Electricity production(% of total) in Croatia and Electricity production(% of total) in Czech Republic?
Offer a terse response. 31.62. In the year 1998, what is the difference between the Electricity production(% of total) of Croatia and Electricity production(% of total) of Paraguay?
Offer a terse response. 32.55. In the year 1998, what is the difference between the Electricity production(% of total) of Czech Republic and Electricity production(% of total) of Paraguay?
Keep it short and to the point. 0.93. In the year 1999, what is the difference between the Electricity production(% of total) of Middle income and Electricity production(% of total) of Croatia?
Your answer should be compact. -20.82. In the year 1999, what is the difference between the Electricity production(% of total) of Middle income and Electricity production(% of total) of Czech Republic?
Offer a very short reply. 10.3. In the year 1999, what is the difference between the Electricity production(% of total) of Middle income and Electricity production(% of total) of Paraguay?
Ensure brevity in your answer.  10.94. In the year 1999, what is the difference between the Electricity production(% of total) in Croatia and Electricity production(% of total) in Czech Republic?
Offer a very short reply. 31.12. In the year 1999, what is the difference between the Electricity production(% of total) in Croatia and Electricity production(% of total) in Paraguay?
Your answer should be very brief. 31.76. In the year 1999, what is the difference between the Electricity production(% of total) of Czech Republic and Electricity production(% of total) of Paraguay?
Ensure brevity in your answer.  0.64. In the year 2010, what is the difference between the Electricity production(% of total) of Middle income and Electricity production(% of total) of Croatia?
Keep it short and to the point. 0.39. In the year 2010, what is the difference between the Electricity production(% of total) in Middle income and Electricity production(% of total) in Czech Republic?
Provide a succinct answer. 4.21. In the year 2010, what is the difference between the Electricity production(% of total) in Middle income and Electricity production(% of total) in Paraguay?
Offer a terse response. 4.39. In the year 2010, what is the difference between the Electricity production(% of total) in Croatia and Electricity production(% of total) in Czech Republic?
Offer a very short reply. 3.81. In the year 2010, what is the difference between the Electricity production(% of total) of Croatia and Electricity production(% of total) of Paraguay?
Give a very brief answer. 4. In the year 2010, what is the difference between the Electricity production(% of total) in Czech Republic and Electricity production(% of total) in Paraguay?
Offer a very short reply. 0.18. In the year 2011, what is the difference between the Electricity production(% of total) in Middle income and Electricity production(% of total) in Croatia?
Offer a very short reply. -2.65. In the year 2011, what is the difference between the Electricity production(% of total) in Middle income and Electricity production(% of total) in Czech Republic?
Keep it short and to the point. 4.27. In the year 2011, what is the difference between the Electricity production(% of total) in Middle income and Electricity production(% of total) in Paraguay?
Provide a short and direct response. 4.38. In the year 2011, what is the difference between the Electricity production(% of total) in Croatia and Electricity production(% of total) in Czech Republic?
Ensure brevity in your answer.  6.91. In the year 2011, what is the difference between the Electricity production(% of total) of Croatia and Electricity production(% of total) of Paraguay?
Offer a terse response. 7.03. In the year 2011, what is the difference between the Electricity production(% of total) of Czech Republic and Electricity production(% of total) of Paraguay?
Provide a short and direct response. 0.11. In the year 2012, what is the difference between the Electricity production(% of total) in Middle income and Electricity production(% of total) in Croatia?
Your answer should be very brief. -1.23. In the year 2012, what is the difference between the Electricity production(% of total) of Middle income and Electricity production(% of total) of Czech Republic?
Your response must be concise. 4.27. In the year 2012, what is the difference between the Electricity production(% of total) of Middle income and Electricity production(% of total) of Paraguay?
Your response must be concise. 4.37. In the year 2012, what is the difference between the Electricity production(% of total) in Croatia and Electricity production(% of total) in Czech Republic?
Your answer should be compact. 5.49. In the year 2012, what is the difference between the Electricity production(% of total) in Croatia and Electricity production(% of total) in Paraguay?
Your response must be concise. 5.59. In the year 2012, what is the difference between the Electricity production(% of total) in Czech Republic and Electricity production(% of total) in Paraguay?
Ensure brevity in your answer.  0.1. What is the ratio of the Electricity production(% of total) in Middle income in 1996 to that in 1997?
Ensure brevity in your answer.  1. What is the ratio of the Electricity production(% of total) of Croatia in 1996 to that in 1997?
Provide a succinct answer. 0.64. What is the ratio of the Electricity production(% of total) in Czech Republic in 1996 to that in 1997?
Your response must be concise. 1.17. What is the ratio of the Electricity production(% of total) in Paraguay in 1996 to that in 1997?
Offer a terse response. 1.55. What is the ratio of the Electricity production(% of total) in Croatia in 1996 to that in 1998?
Make the answer very short. 0.55. What is the ratio of the Electricity production(% of total) in Czech Republic in 1996 to that in 1998?
Offer a terse response. 1.2. What is the ratio of the Electricity production(% of total) in Paraguay in 1996 to that in 1998?
Offer a terse response. 1.55. What is the ratio of the Electricity production(% of total) in Middle income in 1996 to that in 1999?
Give a very brief answer. 1.07. What is the ratio of the Electricity production(% of total) of Croatia in 1996 to that in 1999?
Ensure brevity in your answer.  0.56. What is the ratio of the Electricity production(% of total) of Czech Republic in 1996 to that in 1999?
Make the answer very short. 1.72. What is the ratio of the Electricity production(% of total) in Paraguay in 1996 to that in 1999?
Your response must be concise. 1.16. What is the ratio of the Electricity production(% of total) in Middle income in 1996 to that in 2010?
Provide a succinct answer. 2.67. What is the ratio of the Electricity production(% of total) in Croatia in 1996 to that in 2010?
Ensure brevity in your answer.  4.44. What is the ratio of the Electricity production(% of total) in Czech Republic in 1996 to that in 2010?
Provide a succinct answer. 6.14. What is the ratio of the Electricity production(% of total) in Paraguay in 1996 to that in 2010?
Offer a very short reply. 18.09. What is the ratio of the Electricity production(% of total) in Middle income in 1996 to that in 2011?
Give a very brief answer. 2.68. What is the ratio of the Electricity production(% of total) in Croatia in 1996 to that in 2011?
Keep it short and to the point. 2.53. What is the ratio of the Electricity production(% of total) of Czech Republic in 1996 to that in 2011?
Provide a succinct answer. 10.04. What is the ratio of the Electricity production(% of total) in Paraguay in 1996 to that in 2011?
Your response must be concise. 19.28. What is the ratio of the Electricity production(% of total) in Middle income in 1996 to that in 2012?
Ensure brevity in your answer.  2.69. What is the ratio of the Electricity production(% of total) in Croatia in 1996 to that in 2012?
Offer a terse response. 3.17. What is the ratio of the Electricity production(% of total) of Czech Republic in 1996 to that in 2012?
Provide a short and direct response. 10.92. What is the ratio of the Electricity production(% of total) in Paraguay in 1996 to that in 2012?
Provide a short and direct response. 6.72. What is the ratio of the Electricity production(% of total) in Croatia in 1997 to that in 1998?
Your response must be concise. 0.86. What is the ratio of the Electricity production(% of total) of Czech Republic in 1997 to that in 1998?
Your answer should be compact. 1.03. What is the ratio of the Electricity production(% of total) in Paraguay in 1997 to that in 1998?
Keep it short and to the point. 1. What is the ratio of the Electricity production(% of total) of Middle income in 1997 to that in 1999?
Your answer should be very brief. 1.07. What is the ratio of the Electricity production(% of total) of Croatia in 1997 to that in 1999?
Keep it short and to the point. 0.88. What is the ratio of the Electricity production(% of total) in Czech Republic in 1997 to that in 1999?
Provide a succinct answer. 1.47. What is the ratio of the Electricity production(% of total) of Paraguay in 1997 to that in 1999?
Keep it short and to the point. 0.75. What is the ratio of the Electricity production(% of total) of Middle income in 1997 to that in 2010?
Offer a very short reply. 2.67. What is the ratio of the Electricity production(% of total) in Croatia in 1997 to that in 2010?
Your answer should be very brief. 6.98. What is the ratio of the Electricity production(% of total) in Czech Republic in 1997 to that in 2010?
Your answer should be compact. 5.26. What is the ratio of the Electricity production(% of total) in Paraguay in 1997 to that in 2010?
Provide a short and direct response. 11.69. What is the ratio of the Electricity production(% of total) in Middle income in 1997 to that in 2011?
Give a very brief answer. 2.68. What is the ratio of the Electricity production(% of total) in Croatia in 1997 to that in 2011?
Your answer should be compact. 3.97. What is the ratio of the Electricity production(% of total) of Czech Republic in 1997 to that in 2011?
Provide a succinct answer. 8.61. What is the ratio of the Electricity production(% of total) in Paraguay in 1997 to that in 2011?
Make the answer very short. 12.46. What is the ratio of the Electricity production(% of total) of Middle income in 1997 to that in 2012?
Ensure brevity in your answer.  2.68. What is the ratio of the Electricity production(% of total) of Croatia in 1997 to that in 2012?
Your answer should be very brief. 4.99. What is the ratio of the Electricity production(% of total) in Czech Republic in 1997 to that in 2012?
Your response must be concise. 9.36. What is the ratio of the Electricity production(% of total) of Paraguay in 1997 to that in 2012?
Offer a very short reply. 4.34. What is the ratio of the Electricity production(% of total) of Middle income in 1998 to that in 1999?
Provide a short and direct response. 1.07. What is the ratio of the Electricity production(% of total) of Croatia in 1998 to that in 1999?
Give a very brief answer. 1.02. What is the ratio of the Electricity production(% of total) in Czech Republic in 1998 to that in 1999?
Ensure brevity in your answer.  1.43. What is the ratio of the Electricity production(% of total) of Paraguay in 1998 to that in 1999?
Offer a very short reply. 0.75. What is the ratio of the Electricity production(% of total) of Middle income in 1998 to that in 2010?
Ensure brevity in your answer.  2.67. What is the ratio of the Electricity production(% of total) of Croatia in 1998 to that in 2010?
Ensure brevity in your answer.  8.14. What is the ratio of the Electricity production(% of total) of Czech Republic in 1998 to that in 2010?
Your answer should be very brief. 5.11. What is the ratio of the Electricity production(% of total) in Paraguay in 1998 to that in 2010?
Your answer should be compact. 11.69. What is the ratio of the Electricity production(% of total) in Middle income in 1998 to that in 2011?
Offer a very short reply. 2.67. What is the ratio of the Electricity production(% of total) in Croatia in 1998 to that in 2011?
Make the answer very short. 4.64. What is the ratio of the Electricity production(% of total) in Czech Republic in 1998 to that in 2011?
Make the answer very short. 8.36. What is the ratio of the Electricity production(% of total) of Paraguay in 1998 to that in 2011?
Give a very brief answer. 12.46. What is the ratio of the Electricity production(% of total) in Middle income in 1998 to that in 2012?
Offer a very short reply. 2.68. What is the ratio of the Electricity production(% of total) of Croatia in 1998 to that in 2012?
Your answer should be very brief. 5.82. What is the ratio of the Electricity production(% of total) of Czech Republic in 1998 to that in 2012?
Offer a terse response. 9.1. What is the ratio of the Electricity production(% of total) of Paraguay in 1998 to that in 2012?
Give a very brief answer. 4.34. What is the ratio of the Electricity production(% of total) of Middle income in 1999 to that in 2010?
Make the answer very short. 2.5. What is the ratio of the Electricity production(% of total) of Croatia in 1999 to that in 2010?
Give a very brief answer. 7.95. What is the ratio of the Electricity production(% of total) of Czech Republic in 1999 to that in 2010?
Ensure brevity in your answer.  3.57. What is the ratio of the Electricity production(% of total) in Paraguay in 1999 to that in 2010?
Provide a succinct answer. 15.61. What is the ratio of the Electricity production(% of total) in Middle income in 1999 to that in 2011?
Keep it short and to the point. 2.5. What is the ratio of the Electricity production(% of total) of Croatia in 1999 to that in 2011?
Make the answer very short. 4.52. What is the ratio of the Electricity production(% of total) in Czech Republic in 1999 to that in 2011?
Your answer should be very brief. 5.84. What is the ratio of the Electricity production(% of total) in Paraguay in 1999 to that in 2011?
Offer a very short reply. 16.63. What is the ratio of the Electricity production(% of total) in Middle income in 1999 to that in 2012?
Offer a terse response. 2.51. What is the ratio of the Electricity production(% of total) in Croatia in 1999 to that in 2012?
Offer a terse response. 5.68. What is the ratio of the Electricity production(% of total) in Czech Republic in 1999 to that in 2012?
Keep it short and to the point. 6.35. What is the ratio of the Electricity production(% of total) in Paraguay in 1999 to that in 2012?
Keep it short and to the point. 5.8. What is the ratio of the Electricity production(% of total) in Middle income in 2010 to that in 2011?
Provide a succinct answer. 1. What is the ratio of the Electricity production(% of total) in Croatia in 2010 to that in 2011?
Your answer should be compact. 0.57. What is the ratio of the Electricity production(% of total) in Czech Republic in 2010 to that in 2011?
Make the answer very short. 1.64. What is the ratio of the Electricity production(% of total) in Paraguay in 2010 to that in 2011?
Your answer should be very brief. 1.07. What is the ratio of the Electricity production(% of total) in Middle income in 2010 to that in 2012?
Your answer should be very brief. 1.01. What is the ratio of the Electricity production(% of total) of Croatia in 2010 to that in 2012?
Your response must be concise. 0.71. What is the ratio of the Electricity production(% of total) of Czech Republic in 2010 to that in 2012?
Give a very brief answer. 1.78. What is the ratio of the Electricity production(% of total) in Paraguay in 2010 to that in 2012?
Keep it short and to the point. 0.37. What is the ratio of the Electricity production(% of total) of Croatia in 2011 to that in 2012?
Provide a succinct answer. 1.25. What is the ratio of the Electricity production(% of total) of Czech Republic in 2011 to that in 2012?
Provide a short and direct response. 1.09. What is the ratio of the Electricity production(% of total) in Paraguay in 2011 to that in 2012?
Offer a terse response. 0.35. What is the difference between the highest and the second highest Electricity production(% of total) in Middle income?
Offer a very short reply. 0.01. What is the difference between the highest and the second highest Electricity production(% of total) of Croatia?
Your response must be concise. 0.78. What is the difference between the highest and the second highest Electricity production(% of total) in Czech Republic?
Your answer should be compact. 0.16. What is the difference between the highest and the second highest Electricity production(% of total) in Paraguay?
Keep it short and to the point. 0. What is the difference between the highest and the lowest Electricity production(% of total) in Middle income?
Your answer should be very brief. 7.37. What is the difference between the highest and the lowest Electricity production(% of total) in Croatia?
Offer a very short reply. 28.57. What is the difference between the highest and the lowest Electricity production(% of total) of Czech Republic?
Offer a very short reply. 1.04. What is the difference between the highest and the lowest Electricity production(% of total) of Paraguay?
Make the answer very short. 0.03. 